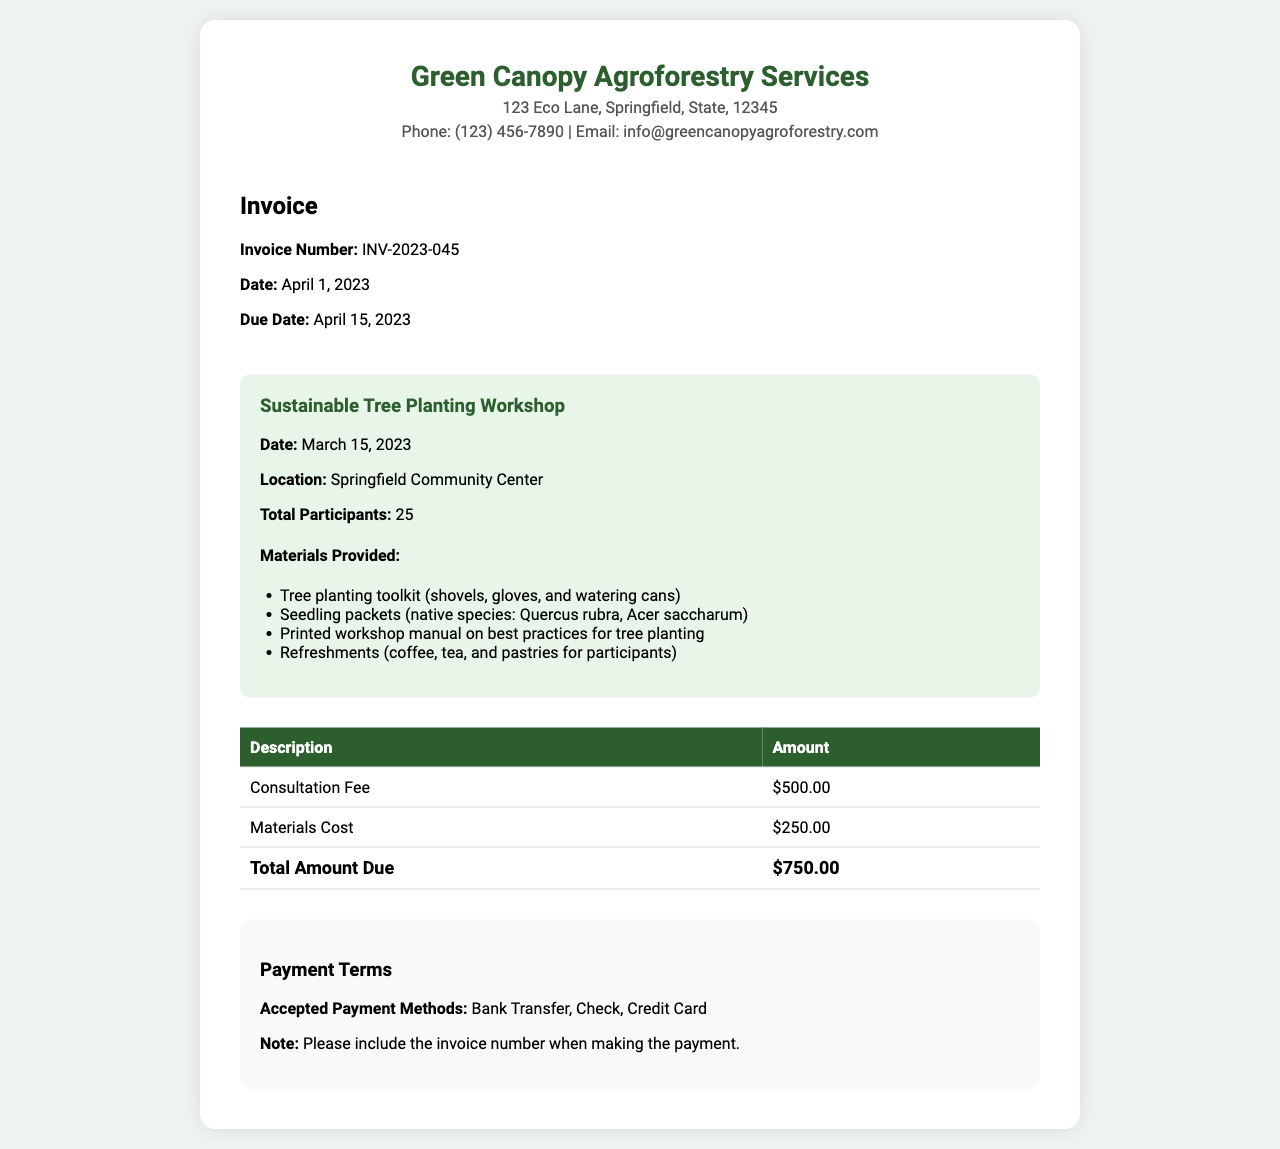What is the invoice number? The invoice number is provided under the invoice details section, specifically labeled.
Answer: INV-2023-045 What is the total number of participants? The document specifies the total number of participants in the workshop details section.
Answer: 25 What is the date of the workshop? The date of the workshop is mentioned in the workshop details section as well.
Answer: March 15, 2023 What is the amount for the consultation fee? The consultation fee amount is listed in the table under the description of services provided.
Answer: $500.00 What materials were provided during the workshop? The materials provided are listed in a bullet point format in the workshop details section.
Answer: Tree planting toolkit, Seedling packets, Printed workshop manual, Refreshments What is the total amount due? The total amount due is clearly stated at the bottom of the invoice table.
Answer: $750.00 What is the payment due date? The due date is specified in the invoice details section and indicates when the payment should be made.
Answer: April 15, 2023 What is the location of the workshop? The workshop's location is mentioned under the workshop details heading.
Answer: Springfield Community Center 